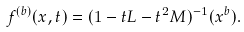Convert formula to latex. <formula><loc_0><loc_0><loc_500><loc_500>f ^ { ( b ) } ( x , t ) = ( 1 - t L - t ^ { 2 } M ) ^ { - 1 } ( x ^ { b } ) .</formula> 